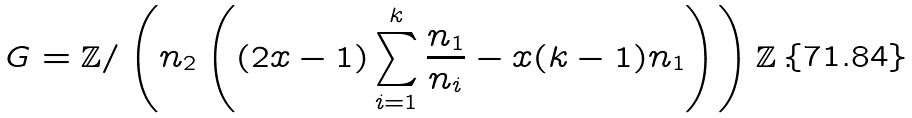<formula> <loc_0><loc_0><loc_500><loc_500>G = \mathbb { Z } / \left ( n _ { 2 } \left ( ( 2 x - 1 ) \sum _ { i = 1 } ^ { k } \frac { n _ { 1 } } { n _ { i } } - x ( k - 1 ) n _ { 1 } \right ) \right ) \mathbb { Z } \, .</formula> 